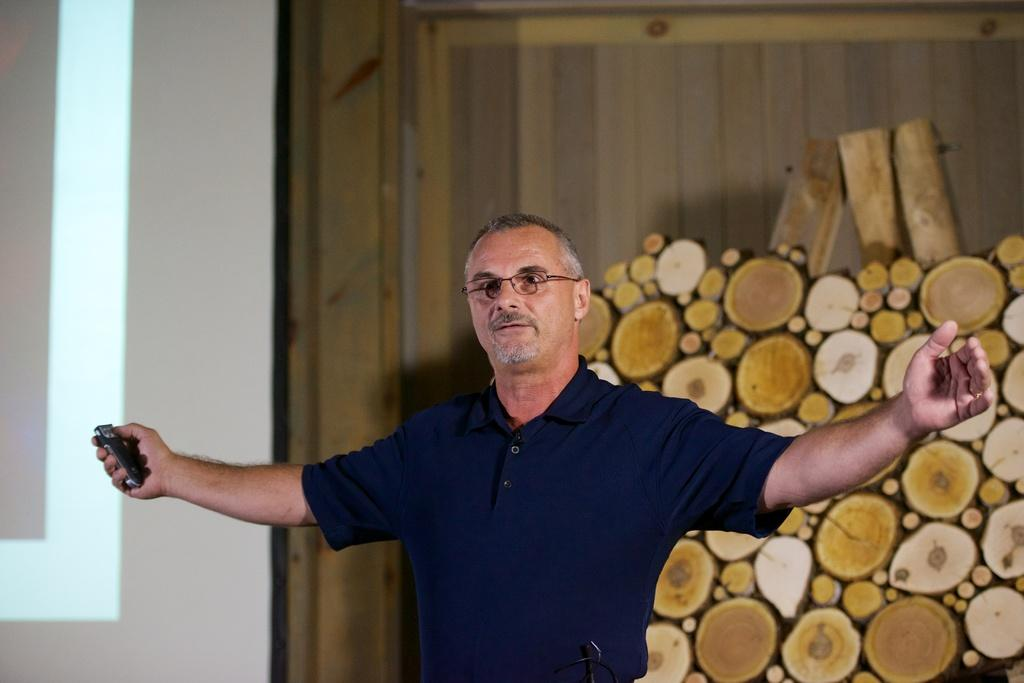What can be seen in the background of the image? There is a wall in the image. Can you describe the person in the image? The person is wearing a blue t-shirt and spectacles. What type of meal is the person eating in the image? There is no meal present in the image; the person is wearing a blue t-shirt and spectacles. What happens to the bottle in the image? There is no bottle present in the image. 